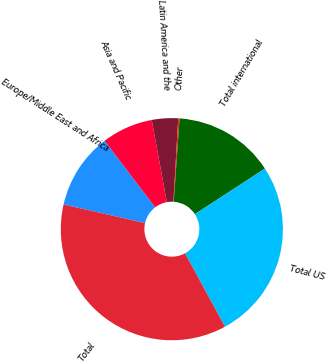Convert chart to OTSL. <chart><loc_0><loc_0><loc_500><loc_500><pie_chart><fcel>Europe/Middle East and Africa<fcel>Asia and Pacific<fcel>Latin America and the<fcel>Other<fcel>Total international<fcel>Total US<fcel>Total<nl><fcel>11.08%<fcel>7.45%<fcel>3.82%<fcel>0.19%<fcel>14.71%<fcel>26.24%<fcel>36.5%<nl></chart> 